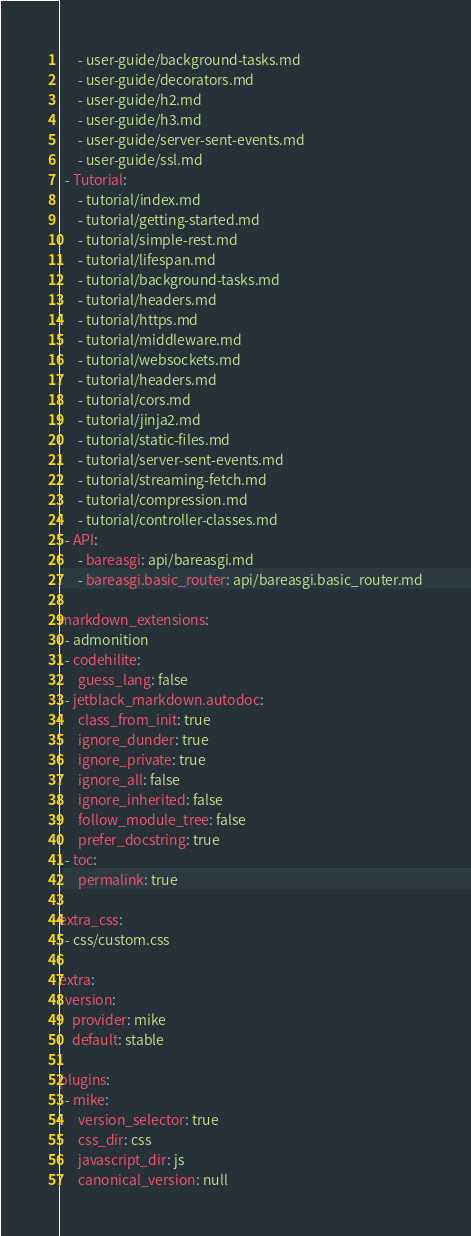Convert code to text. <code><loc_0><loc_0><loc_500><loc_500><_YAML_>      - user-guide/background-tasks.md
      - user-guide/decorators.md
      - user-guide/h2.md
      - user-guide/h3.md
      - user-guide/server-sent-events.md
      - user-guide/ssl.md
  - Tutorial:
      - tutorial/index.md
      - tutorial/getting-started.md
      - tutorial/simple-rest.md
      - tutorial/lifespan.md
      - tutorial/background-tasks.md
      - tutorial/headers.md
      - tutorial/https.md
      - tutorial/middleware.md
      - tutorial/websockets.md
      - tutorial/headers.md
      - tutorial/cors.md
      - tutorial/jinja2.md
      - tutorial/static-files.md
      - tutorial/server-sent-events.md
      - tutorial/streaming-fetch.md
      - tutorial/compression.md
      - tutorial/controller-classes.md
  - API:
      - bareasgi: api/bareasgi.md
      - bareasgi.basic_router: api/bareasgi.basic_router.md

markdown_extensions:
  - admonition
  - codehilite:
      guess_lang: false
  - jetblack_markdown.autodoc:
      class_from_init: true
      ignore_dunder: true
      ignore_private: true
      ignore_all: false
      ignore_inherited: false
      follow_module_tree: false
      prefer_docstring: true
  - toc:
      permalink: true

extra_css:
  - css/custom.css

extra:
  version:
    provider: mike
    default: stable

plugins:
  - mike:
      version_selector: true
      css_dir: css
      javascript_dir: js
      canonical_version: null
</code> 